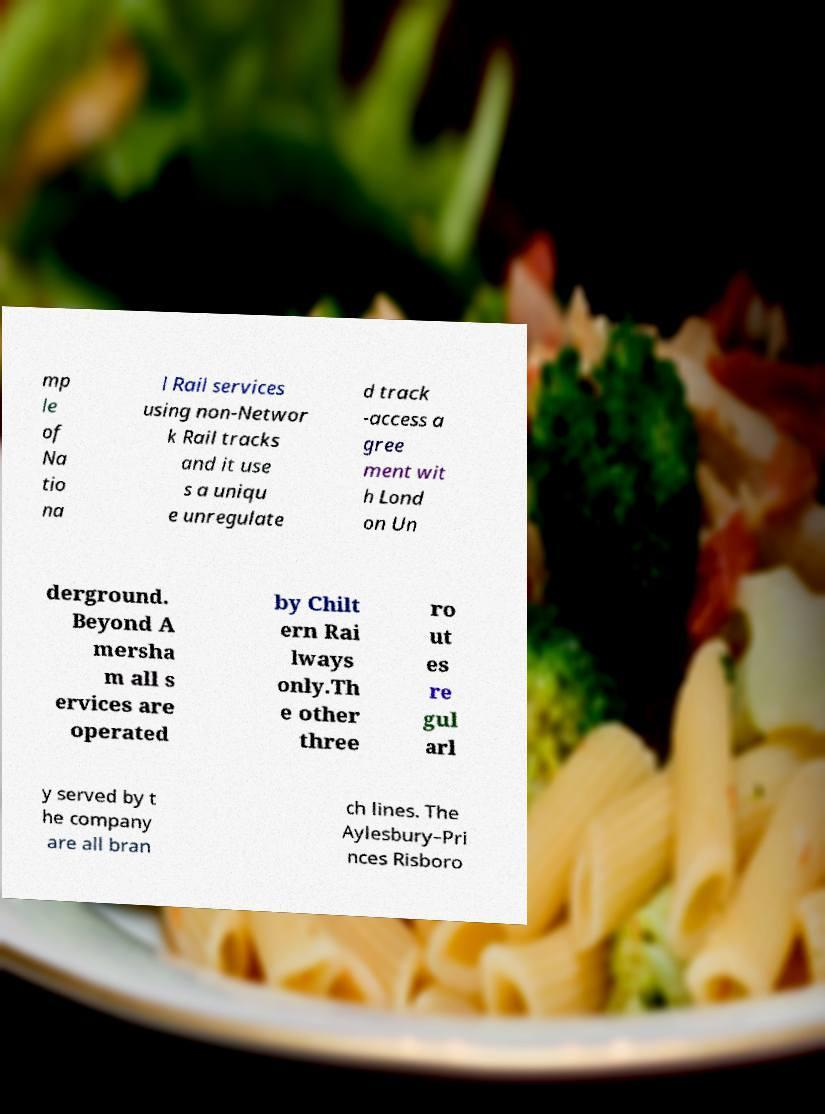There's text embedded in this image that I need extracted. Can you transcribe it verbatim? mp le of Na tio na l Rail services using non-Networ k Rail tracks and it use s a uniqu e unregulate d track -access a gree ment wit h Lond on Un derground. Beyond A mersha m all s ervices are operated by Chilt ern Rai lways only.Th e other three ro ut es re gul arl y served by t he company are all bran ch lines. The Aylesbury–Pri nces Risboro 